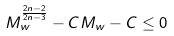<formula> <loc_0><loc_0><loc_500><loc_500>M _ { w } ^ { \frac { 2 n - 2 } { 2 n - 3 } } - C M _ { w } - C \leq 0</formula> 